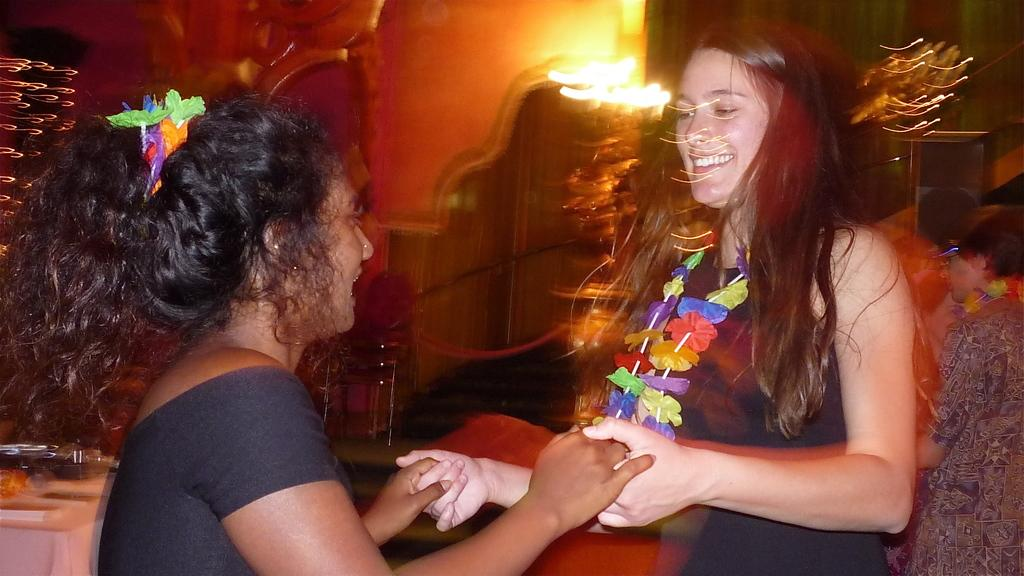How many women are in the image? There are two women in the image. What are the women doing in the image? The women are shaking hands. Can you describe the background of the image? There are people visible in the background of the image. What else can be seen in the image besides the women? There are objects present in the image. How many centimeters of glue are visible on the women's hands in the image? There is no glue visible on the women's hands in the image. Can you count the number of ladybugs present in the image? There are no ladybugs present in the image. 